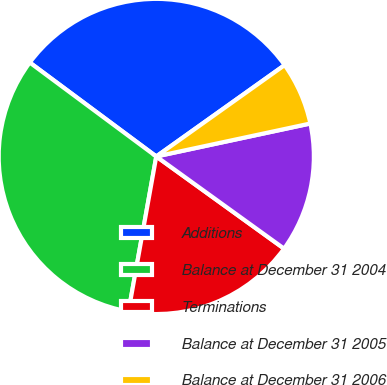Convert chart. <chart><loc_0><loc_0><loc_500><loc_500><pie_chart><fcel>Additions<fcel>Balance at December 31 2004<fcel>Terminations<fcel>Balance at December 31 2005<fcel>Balance at December 31 2006<nl><fcel>29.99%<fcel>32.34%<fcel>17.88%<fcel>13.3%<fcel>6.49%<nl></chart> 